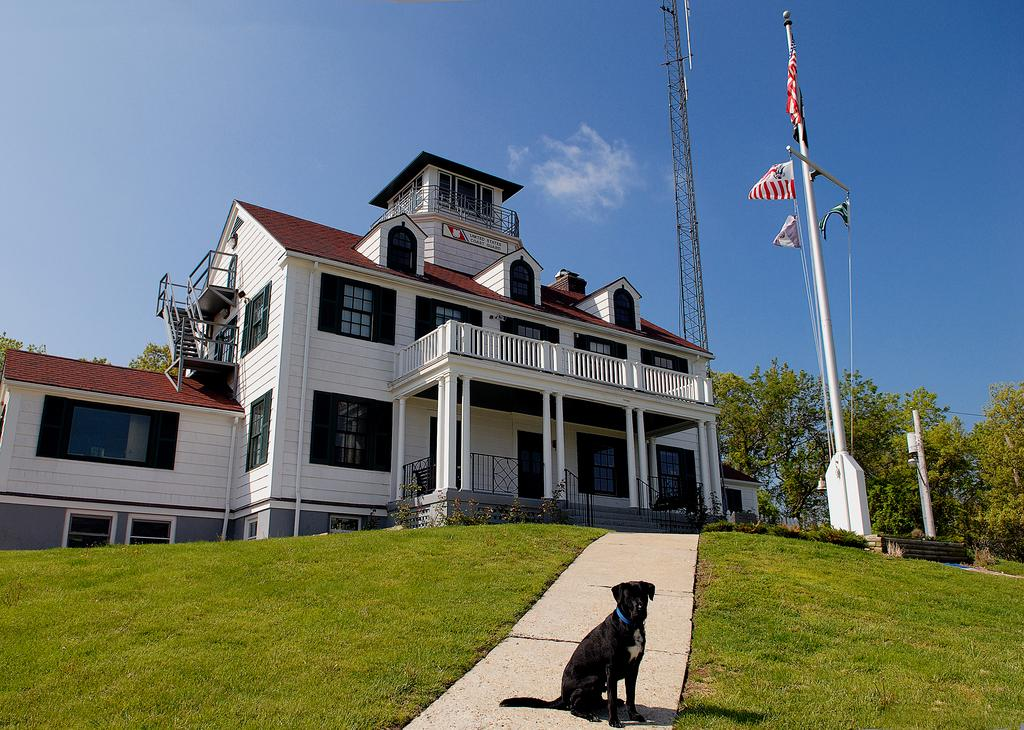What type of animal can be seen in the image? There is a black dog in the image. What is beside the dog in the image? There is grass beside the dog. What can be seen in the background of the image? There is a building, trees, flags, and a tower in the background of the image. Can you describe the building in the background? The building has windows. What else can be seen in the background of the image? There are plants in the background of the image. What type of work does the minister do in the image? There is no minister present in the image, so it is not possible to answer that question. 